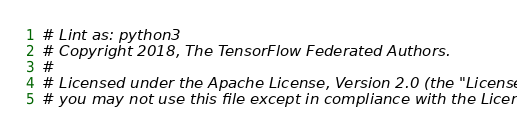<code> <loc_0><loc_0><loc_500><loc_500><_Python_># Lint as: python3
# Copyright 2018, The TensorFlow Federated Authors.
#
# Licensed under the Apache License, Version 2.0 (the "License");
# you may not use this file except in compliance with the License.</code> 